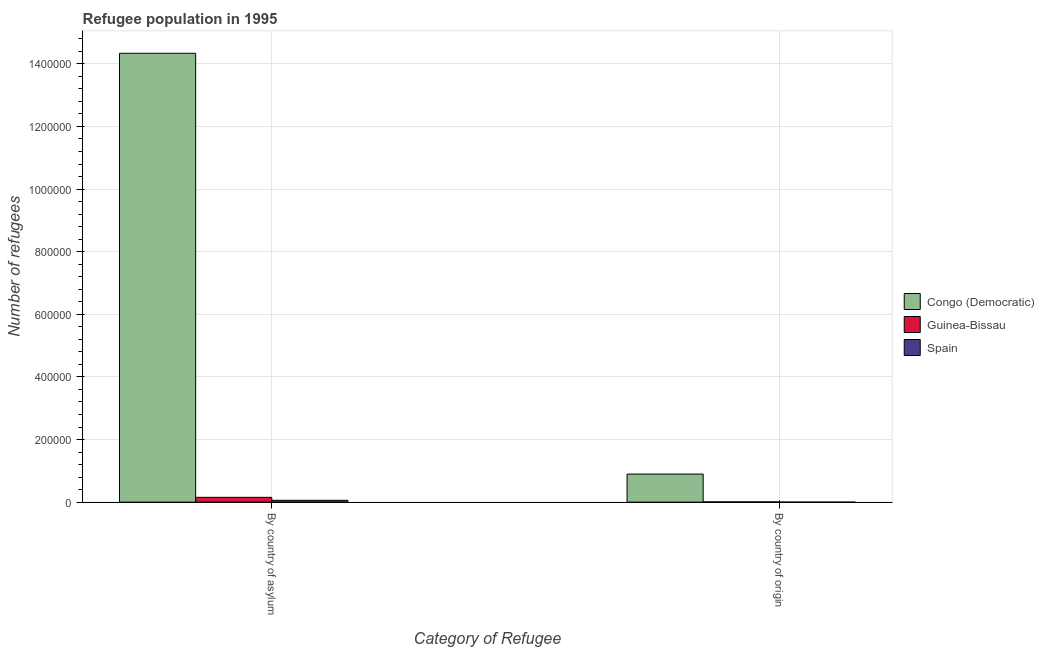How many bars are there on the 2nd tick from the left?
Offer a terse response. 3. How many bars are there on the 1st tick from the right?
Your answer should be compact. 3. What is the label of the 1st group of bars from the left?
Offer a terse response. By country of asylum. What is the number of refugees by country of origin in Spain?
Your answer should be compact. 36. Across all countries, what is the maximum number of refugees by country of asylum?
Make the answer very short. 1.43e+06. Across all countries, what is the minimum number of refugees by country of asylum?
Your answer should be very brief. 5852. In which country was the number of refugees by country of asylum maximum?
Provide a short and direct response. Congo (Democratic). In which country was the number of refugees by country of origin minimum?
Provide a succinct answer. Spain. What is the total number of refugees by country of origin in the graph?
Ensure brevity in your answer.  9.06e+04. What is the difference between the number of refugees by country of asylum in Spain and that in Congo (Democratic)?
Your answer should be very brief. -1.43e+06. What is the difference between the number of refugees by country of asylum in Congo (Democratic) and the number of refugees by country of origin in Guinea-Bissau?
Provide a short and direct response. 1.43e+06. What is the average number of refugees by country of asylum per country?
Keep it short and to the point. 4.85e+05. What is the difference between the number of refugees by country of asylum and number of refugees by country of origin in Congo (Democratic)?
Your answer should be very brief. 1.34e+06. What is the ratio of the number of refugees by country of origin in Spain to that in Guinea-Bissau?
Your response must be concise. 0.04. What does the 3rd bar from the right in By country of asylum represents?
Your response must be concise. Congo (Democratic). Are all the bars in the graph horizontal?
Make the answer very short. No. Where does the legend appear in the graph?
Offer a very short reply. Center right. How many legend labels are there?
Your response must be concise. 3. How are the legend labels stacked?
Your answer should be compact. Vertical. What is the title of the graph?
Your response must be concise. Refugee population in 1995. Does "Lithuania" appear as one of the legend labels in the graph?
Provide a succinct answer. No. What is the label or title of the X-axis?
Ensure brevity in your answer.  Category of Refugee. What is the label or title of the Y-axis?
Your response must be concise. Number of refugees. What is the Number of refugees of Congo (Democratic) in By country of asylum?
Provide a succinct answer. 1.43e+06. What is the Number of refugees in Guinea-Bissau in By country of asylum?
Offer a very short reply. 1.54e+04. What is the Number of refugees of Spain in By country of asylum?
Offer a very short reply. 5852. What is the Number of refugees of Congo (Democratic) in By country of origin?
Ensure brevity in your answer.  8.97e+04. What is the Number of refugees of Guinea-Bissau in By country of origin?
Your response must be concise. 830. Across all Category of Refugee, what is the maximum Number of refugees in Congo (Democratic)?
Give a very brief answer. 1.43e+06. Across all Category of Refugee, what is the maximum Number of refugees in Guinea-Bissau?
Offer a terse response. 1.54e+04. Across all Category of Refugee, what is the maximum Number of refugees in Spain?
Make the answer very short. 5852. Across all Category of Refugee, what is the minimum Number of refugees of Congo (Democratic)?
Offer a very short reply. 8.97e+04. Across all Category of Refugee, what is the minimum Number of refugees in Guinea-Bissau?
Your response must be concise. 830. What is the total Number of refugees in Congo (Democratic) in the graph?
Your response must be concise. 1.52e+06. What is the total Number of refugees in Guinea-Bissau in the graph?
Give a very brief answer. 1.62e+04. What is the total Number of refugees in Spain in the graph?
Offer a very short reply. 5888. What is the difference between the Number of refugees in Congo (Democratic) in By country of asylum and that in By country of origin?
Offer a terse response. 1.34e+06. What is the difference between the Number of refugees of Guinea-Bissau in By country of asylum and that in By country of origin?
Offer a terse response. 1.45e+04. What is the difference between the Number of refugees in Spain in By country of asylum and that in By country of origin?
Your answer should be compact. 5816. What is the difference between the Number of refugees of Congo (Democratic) in By country of asylum and the Number of refugees of Guinea-Bissau in By country of origin?
Provide a succinct answer. 1.43e+06. What is the difference between the Number of refugees of Congo (Democratic) in By country of asylum and the Number of refugees of Spain in By country of origin?
Keep it short and to the point. 1.43e+06. What is the difference between the Number of refugees of Guinea-Bissau in By country of asylum and the Number of refugees of Spain in By country of origin?
Your answer should be very brief. 1.53e+04. What is the average Number of refugees in Congo (Democratic) per Category of Refugee?
Provide a short and direct response. 7.62e+05. What is the average Number of refugees of Guinea-Bissau per Category of Refugee?
Offer a terse response. 8090. What is the average Number of refugees in Spain per Category of Refugee?
Your answer should be compact. 2944. What is the difference between the Number of refugees of Congo (Democratic) and Number of refugees of Guinea-Bissau in By country of asylum?
Keep it short and to the point. 1.42e+06. What is the difference between the Number of refugees of Congo (Democratic) and Number of refugees of Spain in By country of asylum?
Make the answer very short. 1.43e+06. What is the difference between the Number of refugees in Guinea-Bissau and Number of refugees in Spain in By country of asylum?
Provide a succinct answer. 9498. What is the difference between the Number of refugees in Congo (Democratic) and Number of refugees in Guinea-Bissau in By country of origin?
Provide a succinct answer. 8.89e+04. What is the difference between the Number of refugees of Congo (Democratic) and Number of refugees of Spain in By country of origin?
Offer a very short reply. 8.97e+04. What is the difference between the Number of refugees of Guinea-Bissau and Number of refugees of Spain in By country of origin?
Give a very brief answer. 794. What is the ratio of the Number of refugees in Congo (Democratic) in By country of asylum to that in By country of origin?
Your answer should be very brief. 15.98. What is the ratio of the Number of refugees in Guinea-Bissau in By country of asylum to that in By country of origin?
Your response must be concise. 18.49. What is the ratio of the Number of refugees of Spain in By country of asylum to that in By country of origin?
Offer a very short reply. 162.56. What is the difference between the highest and the second highest Number of refugees in Congo (Democratic)?
Offer a terse response. 1.34e+06. What is the difference between the highest and the second highest Number of refugees of Guinea-Bissau?
Make the answer very short. 1.45e+04. What is the difference between the highest and the second highest Number of refugees of Spain?
Make the answer very short. 5816. What is the difference between the highest and the lowest Number of refugees of Congo (Democratic)?
Provide a succinct answer. 1.34e+06. What is the difference between the highest and the lowest Number of refugees in Guinea-Bissau?
Provide a succinct answer. 1.45e+04. What is the difference between the highest and the lowest Number of refugees in Spain?
Provide a succinct answer. 5816. 